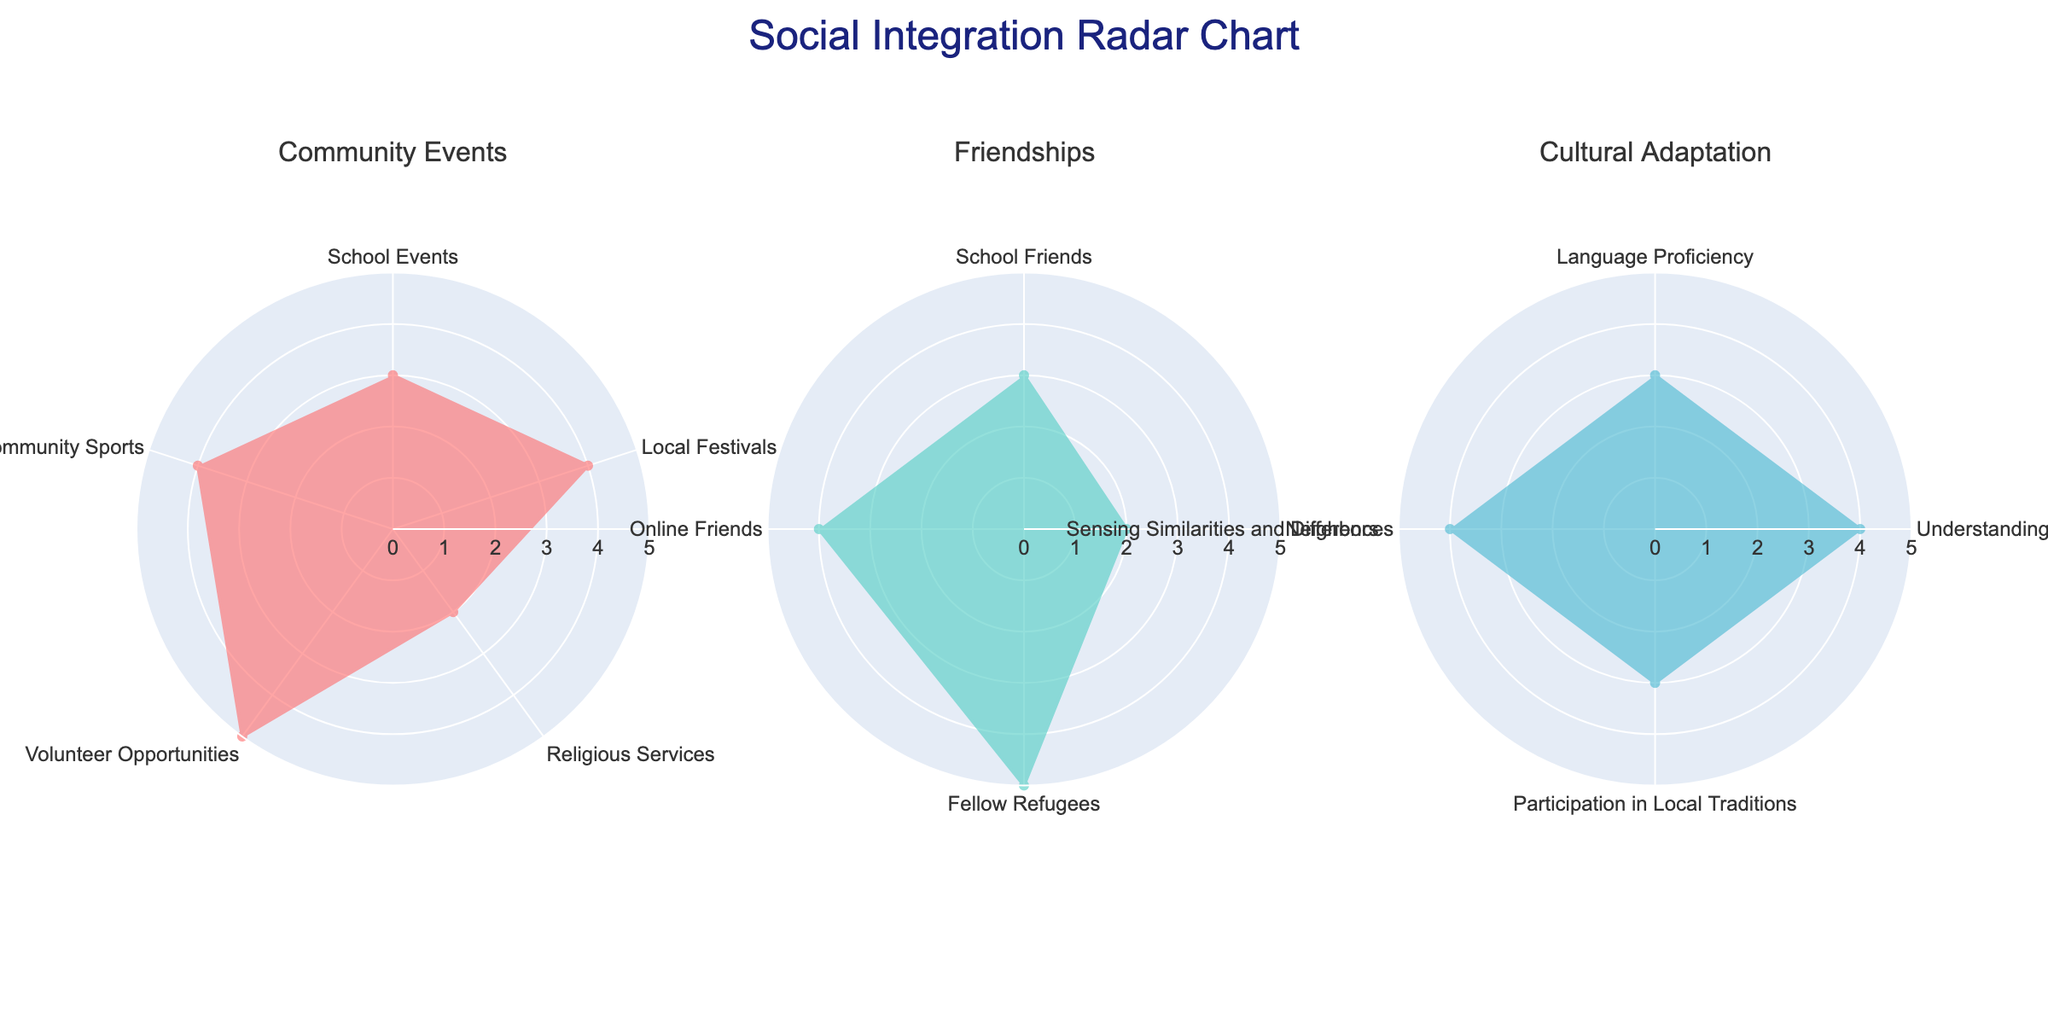What's the title of the chart? The title of the chart is located at the top center. It states "Social Integration Radar Chart".
Answer: Social Integration Radar Chart What color is used for the lines representing 'Community Events'? The color of the lines for 'Community Events' can be identified by looking at the segment in the first radar subplot. It appears as a specific shade of red.
Answer: Red How many subplots are in the figure? The figure contains three distinct radar subplots, as indicated by the specific segments for 'Community Events', 'Friendships', and 'Cultural Adaptation'.
Answer: 3 Which category has the highest value in 'Friendships'? By reviewing the values for each parameter within the 'Friendships' subplot, 'Fellow Refugees' has the highest value.
Answer: Fellow Refugees What is the average value of the parameters in 'Community Events'? The values for 'Community Events' are 3, 4, 2, 5, and 4. Adding them up gives 18, and dividing by the number of parameters (5) gives an average of 3.6.
Answer: 3.6 Compare the value of 'School Friends' in 'Friendships' with 'School Events' in 'Community Events'. Which is higher? The value of 'School Friends' is 3, and the value of 'School Events' is also 3. Therefore, they are equal.
Answer: Equal Which category has a perfect score for any of its parameters? By checking each subplot, 'Community Events' has a parameter with a value of 5, specifically the 'Volunteer Opportunities'.
Answer: Community Events What is the difference between the 'Language Proficiency' and 'Understanding of Local Customs' in 'Cultural Adaptation'? 'Language Proficiency' has a value of 3, and 'Understanding of Local Customs' has a value of 4. The difference is 4 - 3 = 1.
Answer: 1 Which category has the lowest overall performance if you sum all its values? Summing the values in each category: 
- 'Community Events': 3+4+2+5+4 = 18
- 'Friendships': 3+2+5+4 = 14
- 'Cultural Adaptation': 3+4+3+4 = 14
Both 'Friendships' and 'Cultural Adaptation' sum to 14, but they are tied and both have the lowest overall performance.
Answer: Friendships and Cultural Adaptation 